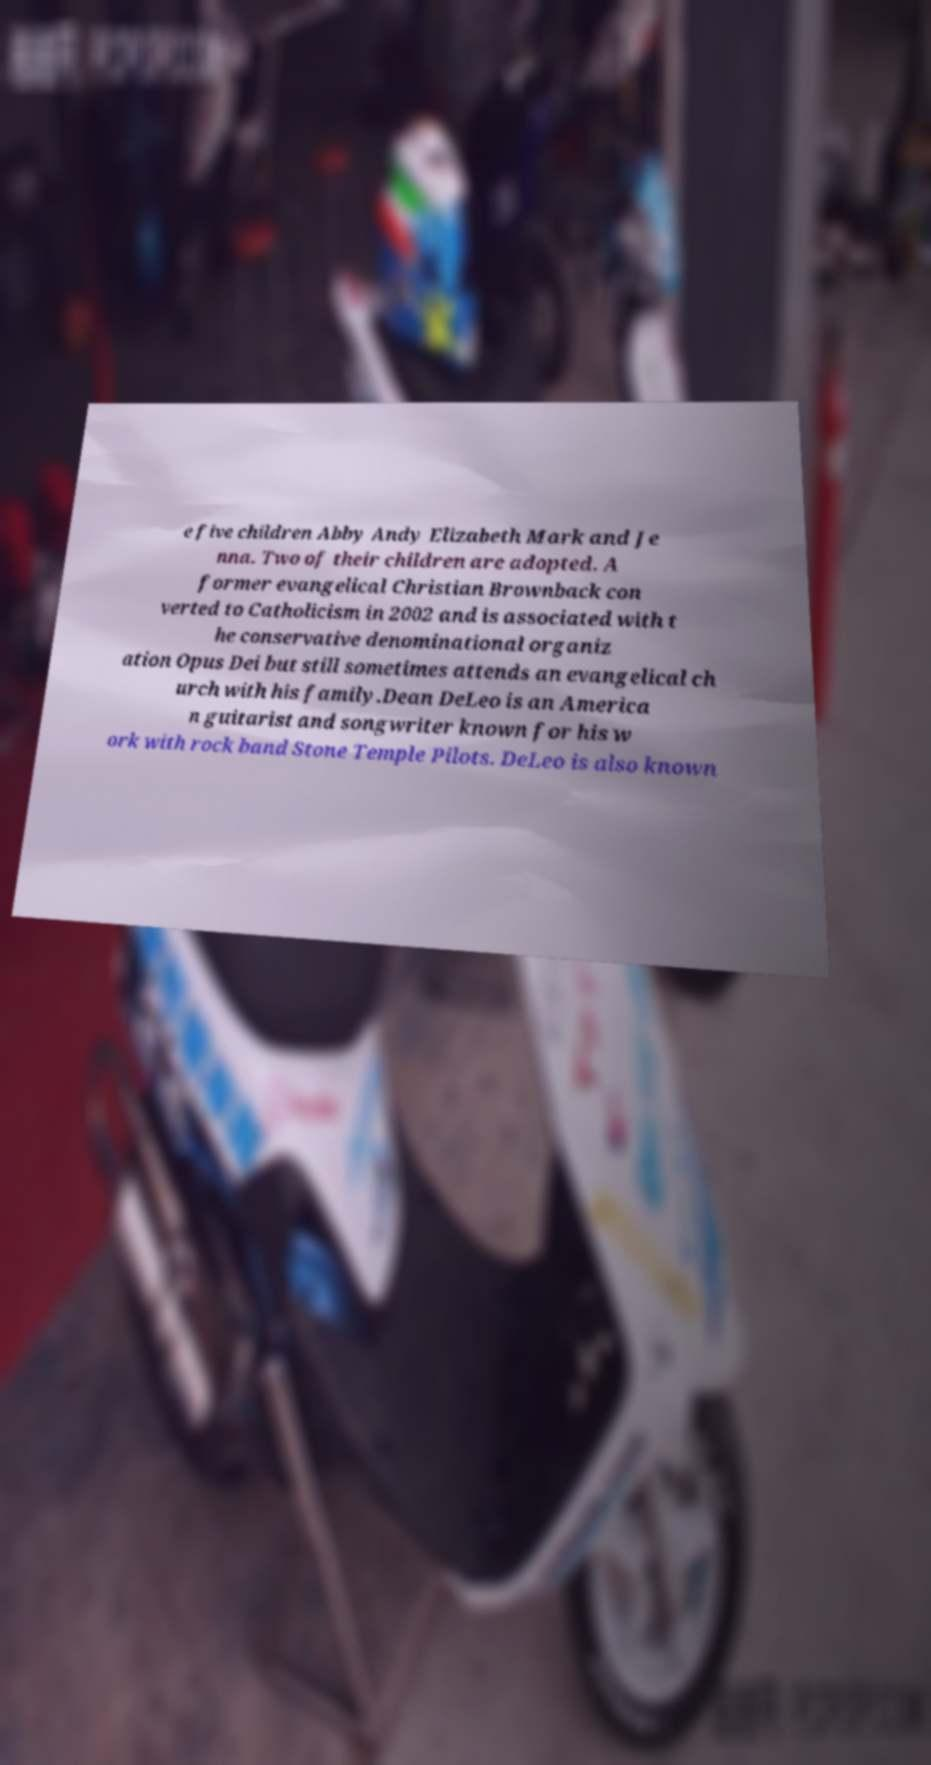Please identify and transcribe the text found in this image. e five children Abby Andy Elizabeth Mark and Je nna. Two of their children are adopted. A former evangelical Christian Brownback con verted to Catholicism in 2002 and is associated with t he conservative denominational organiz ation Opus Dei but still sometimes attends an evangelical ch urch with his family.Dean DeLeo is an America n guitarist and songwriter known for his w ork with rock band Stone Temple Pilots. DeLeo is also known 